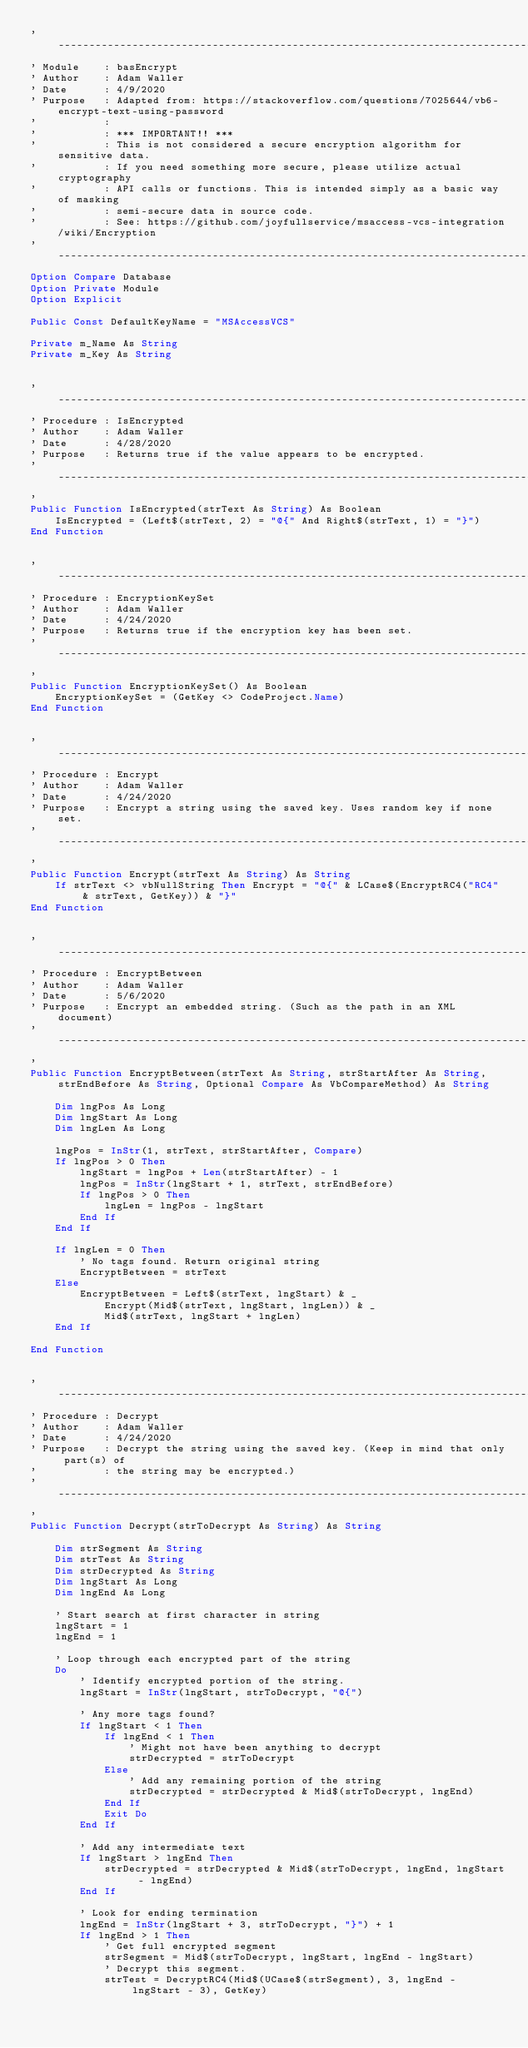Convert code to text. <code><loc_0><loc_0><loc_500><loc_500><_VisualBasic_>'---------------------------------------------------------------------------------------
' Module    : basEncrypt
' Author    : Adam Waller
' Date      : 4/9/2020
' Purpose   : Adapted from: https://stackoverflow.com/questions/7025644/vb6-encrypt-text-using-password
'           :
'           : *** IMPORTANT!! ***
'           : This is not considered a secure encryption algorithm for sensitive data.
'           : If you need something more secure, please utilize actual cryptography
'           : API calls or functions. This is intended simply as a basic way of masking
'           : semi-secure data in source code.
'           : See: https://github.com/joyfullservice/msaccess-vcs-integration/wiki/Encryption
'---------------------------------------------------------------------------------------
Option Compare Database
Option Private Module
Option Explicit

Public Const DefaultKeyName = "MSAccessVCS"

Private m_Name As String
Private m_Key As String


'---------------------------------------------------------------------------------------
' Procedure : IsEncrypted
' Author    : Adam Waller
' Date      : 4/28/2020
' Purpose   : Returns true if the value appears to be encrypted.
'---------------------------------------------------------------------------------------
'
Public Function IsEncrypted(strText As String) As Boolean
    IsEncrypted = (Left$(strText, 2) = "@{" And Right$(strText, 1) = "}")
End Function


'---------------------------------------------------------------------------------------
' Procedure : EncryptionKeySet
' Author    : Adam Waller
' Date      : 4/24/2020
' Purpose   : Returns true if the encryption key has been set.
'---------------------------------------------------------------------------------------
'
Public Function EncryptionKeySet() As Boolean
    EncryptionKeySet = (GetKey <> CodeProject.Name)
End Function


'---------------------------------------------------------------------------------------
' Procedure : Encrypt
' Author    : Adam Waller
' Date      : 4/24/2020
' Purpose   : Encrypt a string using the saved key. Uses random key if none set.
'---------------------------------------------------------------------------------------
'
Public Function Encrypt(strText As String) As String
    If strText <> vbNullString Then Encrypt = "@{" & LCase$(EncryptRC4("RC4" & strText, GetKey)) & "}"
End Function


'---------------------------------------------------------------------------------------
' Procedure : EncryptBetween
' Author    : Adam Waller
' Date      : 5/6/2020
' Purpose   : Encrypt an embedded string. (Such as the path in an XML document)
'---------------------------------------------------------------------------------------
'
Public Function EncryptBetween(strText As String, strStartAfter As String, strEndBefore As String, Optional Compare As VbCompareMethod) As String
    
    Dim lngPos As Long
    Dim lngStart As Long
    Dim lngLen As Long
    
    lngPos = InStr(1, strText, strStartAfter, Compare)
    If lngPos > 0 Then
        lngStart = lngPos + Len(strStartAfter) - 1
        lngPos = InStr(lngStart + 1, strText, strEndBefore)
        If lngPos > 0 Then
            lngLen = lngPos - lngStart
        End If
    End If
    
    If lngLen = 0 Then
        ' No tags found. Return original string
        EncryptBetween = strText
    Else
        EncryptBetween = Left$(strText, lngStart) & _
            Encrypt(Mid$(strText, lngStart, lngLen)) & _
            Mid$(strText, lngStart + lngLen)
    End If
    
End Function


'---------------------------------------------------------------------------------------
' Procedure : Decrypt
' Author    : Adam Waller
' Date      : 4/24/2020
' Purpose   : Decrypt the string using the saved key. (Keep in mind that only part(s) of
'           : the string may be encrypted.)
'---------------------------------------------------------------------------------------
'
Public Function Decrypt(strToDecrypt As String) As String

    Dim strSegment As String
    Dim strTest As String
    Dim strDecrypted As String
    Dim lngStart As Long
    Dim lngEnd As Long
    
    ' Start search at first character in string
    lngStart = 1
    lngEnd = 1
    
    ' Loop through each encrypted part of the string
    Do
        ' Identify encrypted portion of the string.
        lngStart = InStr(lngStart, strToDecrypt, "@{")
    
        ' Any more tags found?
        If lngStart < 1 Then
            If lngEnd < 1 Then
                ' Might not have been anything to decrypt
                strDecrypted = strToDecrypt
            Else
                ' Add any remaining portion of the string
                strDecrypted = strDecrypted & Mid$(strToDecrypt, lngEnd)
            End If
            Exit Do
        End If
    
        ' Add any intermediate text
        If lngStart > lngEnd Then
            strDecrypted = strDecrypted & Mid$(strToDecrypt, lngEnd, lngStart - lngEnd)
        End If
        
        ' Look for ending termination
        lngEnd = InStr(lngStart + 3, strToDecrypt, "}") + 1
        If lngEnd > 1 Then
            ' Get full encrypted segment
            strSegment = Mid$(strToDecrypt, lngStart, lngEnd - lngStart)
            ' Decrypt this segment.
            strTest = DecryptRC4(Mid$(UCase$(strSegment), 3, lngEnd - lngStart - 3), GetKey)</code> 